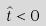Convert formula to latex. <formula><loc_0><loc_0><loc_500><loc_500>\hat { t } < 0</formula> 